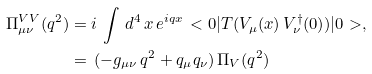Convert formula to latex. <formula><loc_0><loc_0><loc_500><loc_500>\Pi _ { \mu \nu } ^ { V V } ( q ^ { 2 } ) & = i \, \int \, d ^ { 4 } \, x \, e ^ { i q x } \, < 0 | T ( V _ { \mu } ( x ) \, V _ { \nu } ^ { \dagger } ( 0 ) ) | 0 > , \\ & = \, ( - g _ { \mu \nu } \, q ^ { 2 } + q _ { \mu } q _ { \nu } ) \, \Pi _ { V } ( q ^ { 2 } ) \,</formula> 